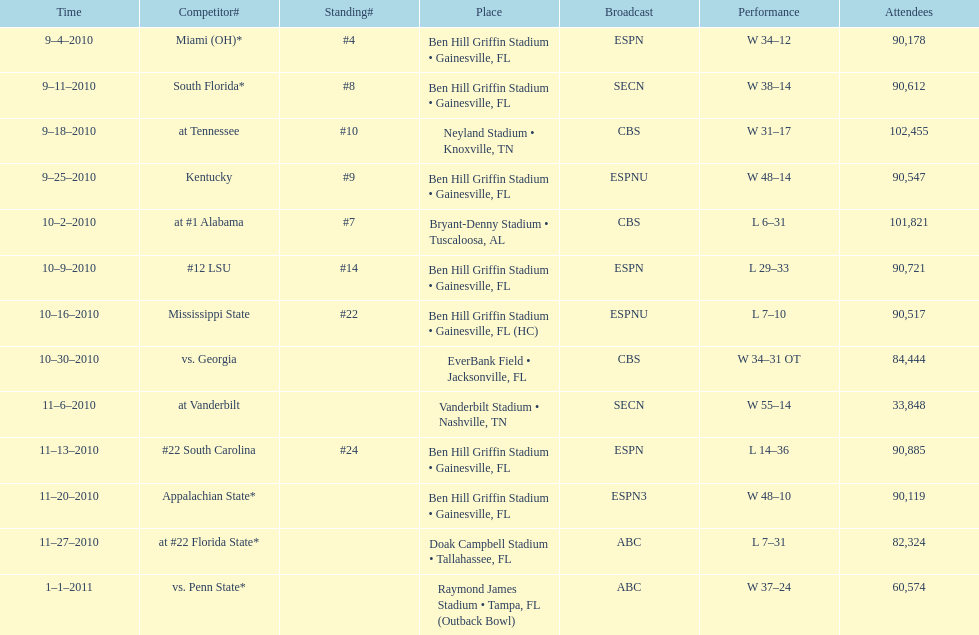How many consecutive weeks did the the gators win until the had their first lost in the 2010 season? 4. 